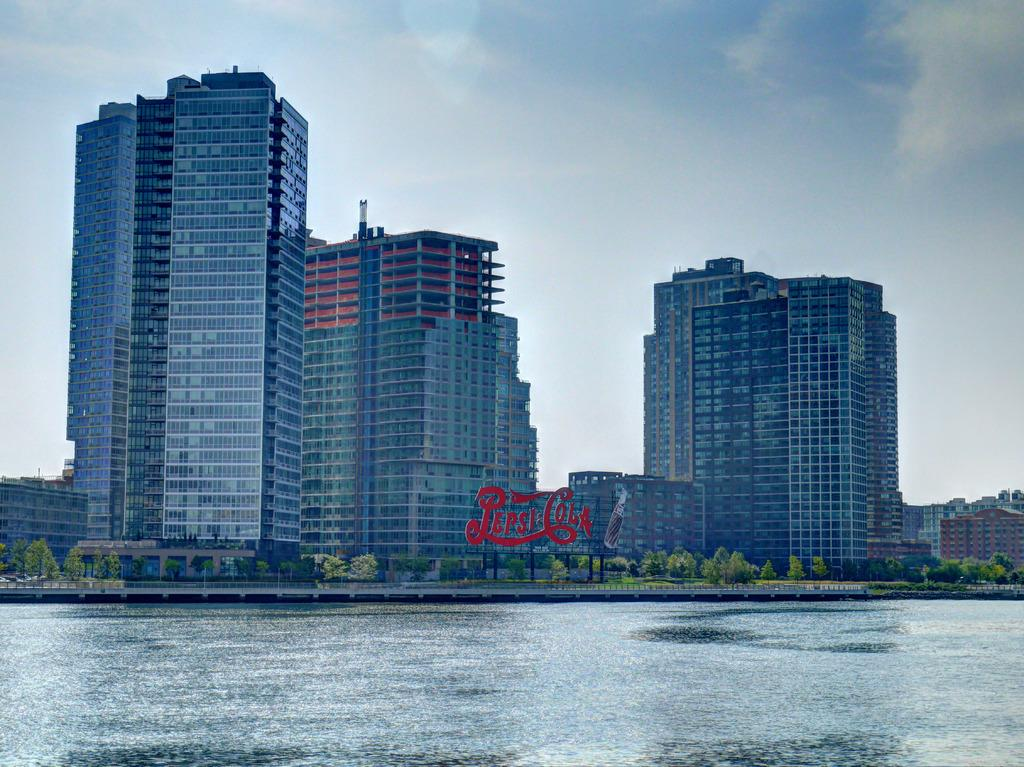What is present in the foreground of the image? There is water visible in the image. What can be seen in the background of the image? There are many trees, buildings, and the sky visible in the background of the image. Can you describe the natural environment in the image? The natural environment in the image includes trees and water. What type of structures are visible in the background? Buildings are visible in the background of the image. What type of apparel is the water wearing in the image? The water does not wear apparel, as it is a natural element and not a living being. 